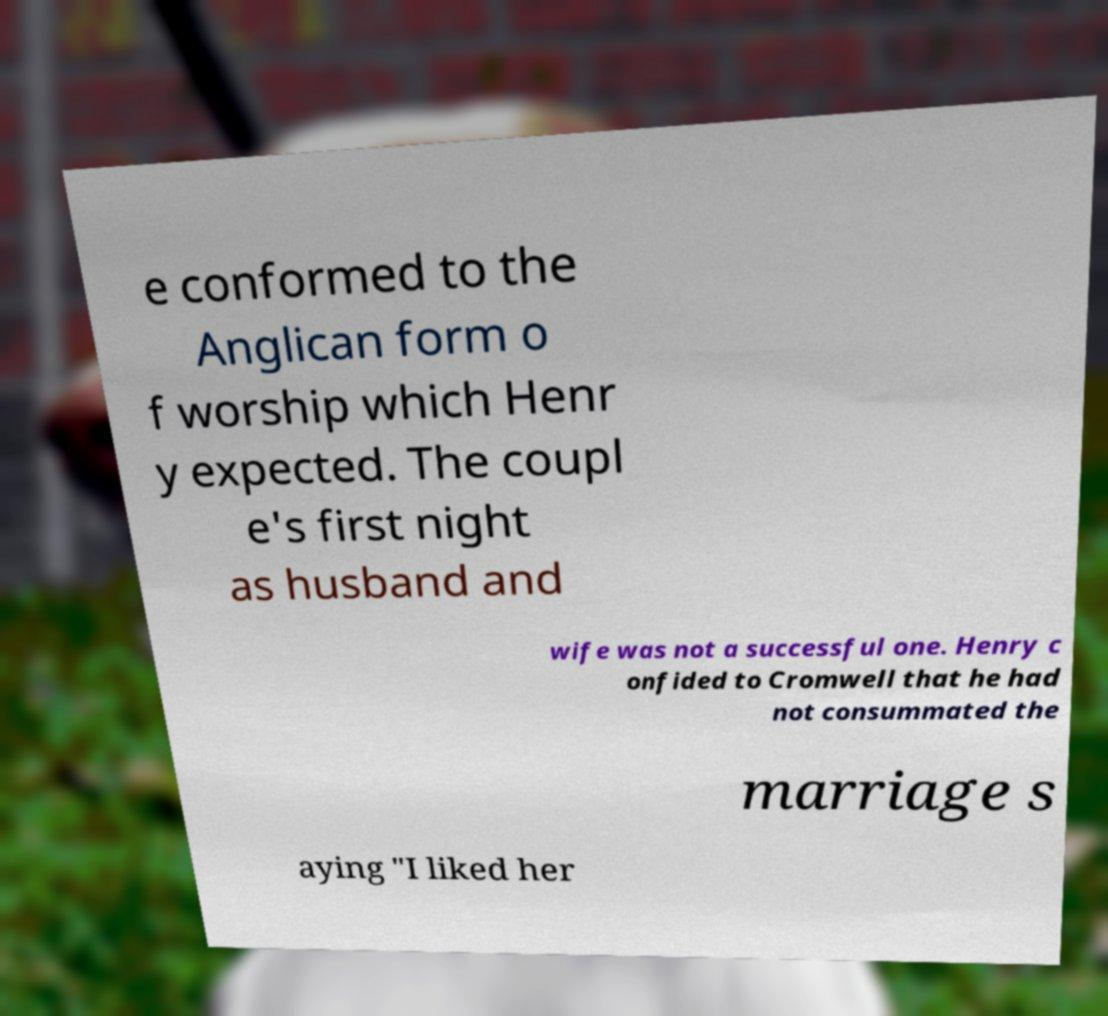Can you accurately transcribe the text from the provided image for me? e conformed to the Anglican form o f worship which Henr y expected. The coupl e's first night as husband and wife was not a successful one. Henry c onfided to Cromwell that he had not consummated the marriage s aying "I liked her 